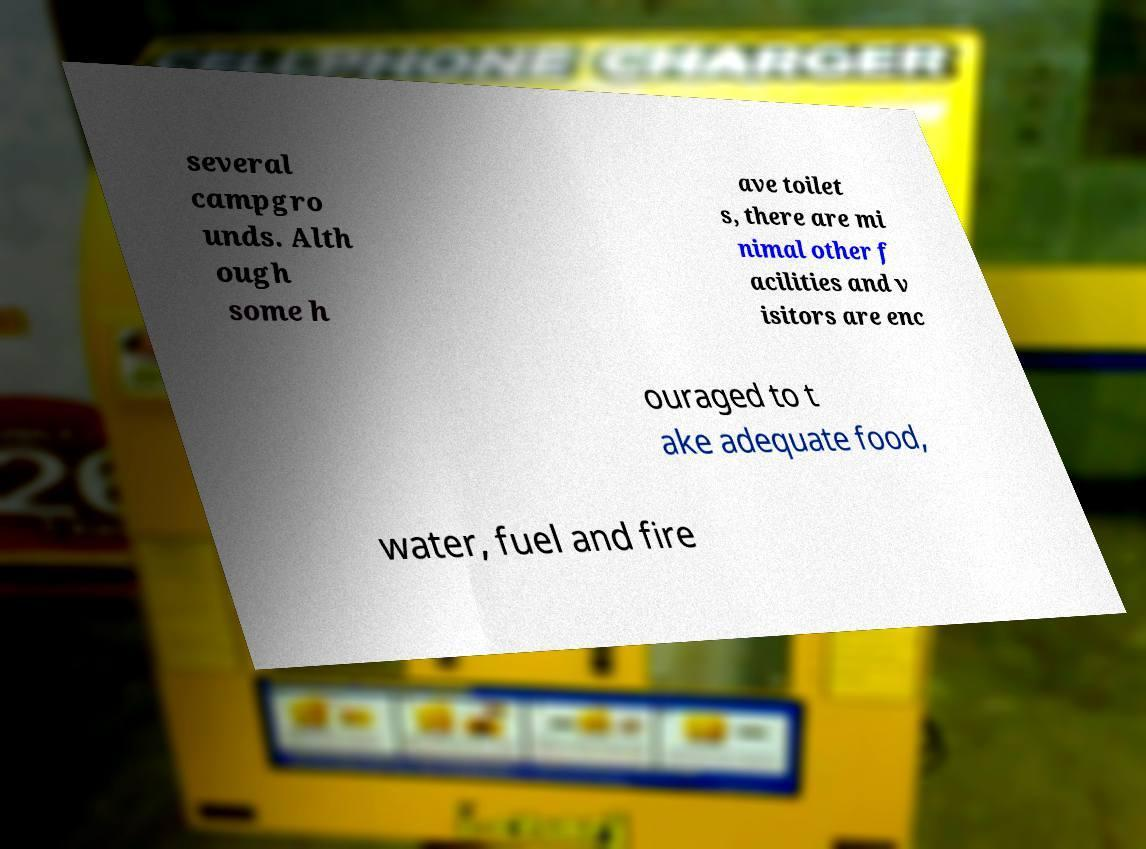Could you extract and type out the text from this image? several campgro unds. Alth ough some h ave toilet s, there are mi nimal other f acilities and v isitors are enc ouraged to t ake adequate food, water, fuel and fire 